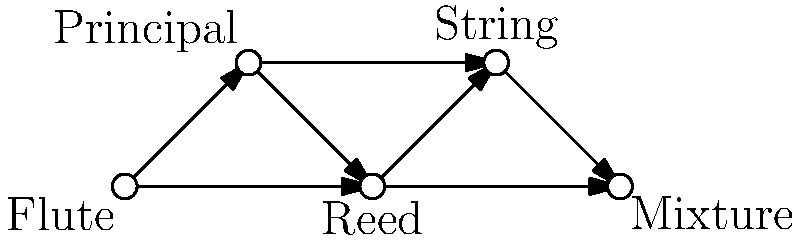In the organ stop connectivity diagram above, what is the minimum number of edges that need to be removed to disconnect the "Flute" stop from the "Mixture" stop? To solve this problem, we need to find the minimum cut between the "Flute" and "Mixture" stops. Let's approach this step-by-step:

1. Identify all possible paths from "Flute" to "Mixture":
   a. Flute → Principal → Reed → String → Mixture
   b. Flute → Principal → String → Mixture
   c. Flute → Reed → String → Mixture
   d. Flute → Reed → Mixture

2. Observe that all paths must go through either:
   - The edge Flute → Principal and then to Mixture, or
   - The edge Flute → Reed and then to Mixture

3. This means that if we remove both edges:
   - Flute → Principal
   - Flute → Reed

   We will disconnect Flute from Mixture.

4. Check if removing fewer edges is possible:
   - If we remove only one of these edges, there will still be a path from Flute to Mixture through the other edge.
   - There's no single edge that, if removed, would disconnect Flute from Mixture.

5. Therefore, the minimum number of edges that need to be removed is 2.

This concept in graph theory is known as the min-cut between two vertices, which is equal to the max-flow according to the max-flow min-cut theorem.
Answer: 2 